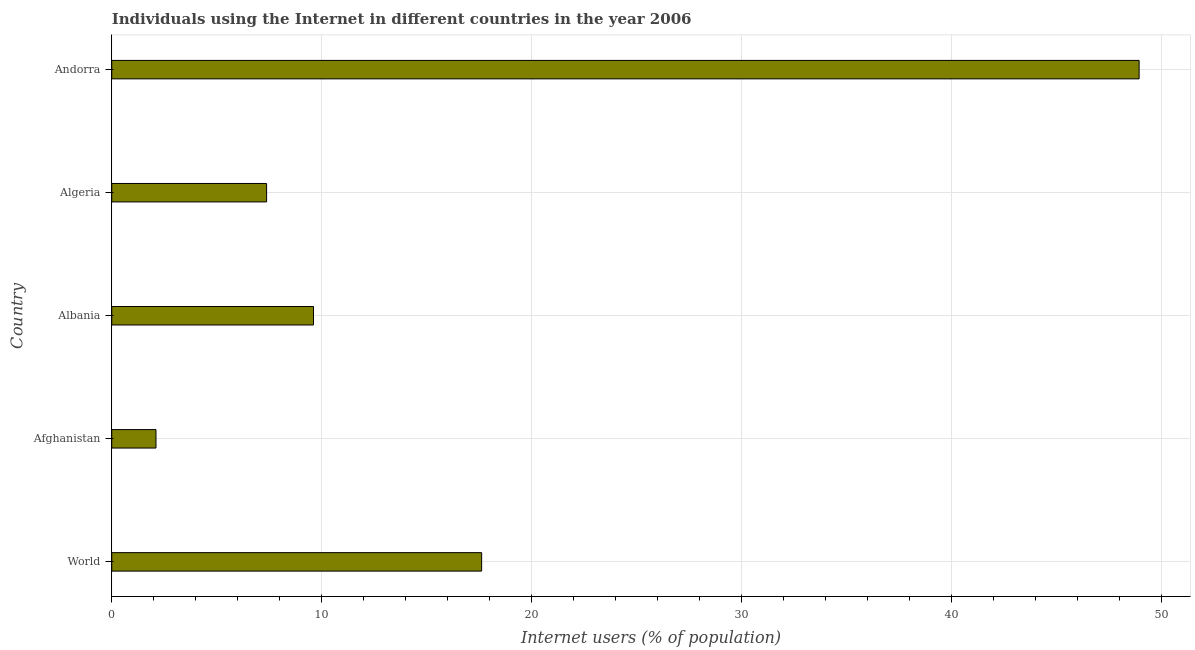Does the graph contain any zero values?
Keep it short and to the point. No. Does the graph contain grids?
Keep it short and to the point. Yes. What is the title of the graph?
Offer a terse response. Individuals using the Internet in different countries in the year 2006. What is the label or title of the X-axis?
Ensure brevity in your answer.  Internet users (% of population). What is the label or title of the Y-axis?
Offer a very short reply. Country. What is the number of internet users in World?
Offer a very short reply. 17.62. Across all countries, what is the maximum number of internet users?
Provide a short and direct response. 48.94. Across all countries, what is the minimum number of internet users?
Your answer should be very brief. 2.11. In which country was the number of internet users maximum?
Provide a succinct answer. Andorra. In which country was the number of internet users minimum?
Your response must be concise. Afghanistan. What is the sum of the number of internet users?
Offer a terse response. 85.65. What is the difference between the number of internet users in Afghanistan and Algeria?
Give a very brief answer. -5.27. What is the average number of internet users per country?
Offer a terse response. 17.13. What is the median number of internet users?
Keep it short and to the point. 9.61. In how many countries, is the number of internet users greater than 32 %?
Offer a very short reply. 1. What is the ratio of the number of internet users in Afghanistan to that in Albania?
Offer a terse response. 0.22. Is the number of internet users in Andorra less than that in World?
Keep it short and to the point. No. Is the difference between the number of internet users in Andorra and World greater than the difference between any two countries?
Keep it short and to the point. No. What is the difference between the highest and the second highest number of internet users?
Your answer should be compact. 31.32. What is the difference between the highest and the lowest number of internet users?
Give a very brief answer. 46.83. How many bars are there?
Your answer should be very brief. 5. Are all the bars in the graph horizontal?
Your answer should be compact. Yes. How many countries are there in the graph?
Your answer should be compact. 5. What is the difference between two consecutive major ticks on the X-axis?
Your answer should be compact. 10. Are the values on the major ticks of X-axis written in scientific E-notation?
Offer a very short reply. No. What is the Internet users (% of population) of World?
Ensure brevity in your answer.  17.62. What is the Internet users (% of population) in Afghanistan?
Ensure brevity in your answer.  2.11. What is the Internet users (% of population) of Albania?
Offer a terse response. 9.61. What is the Internet users (% of population) of Algeria?
Ensure brevity in your answer.  7.38. What is the Internet users (% of population) of Andorra?
Offer a very short reply. 48.94. What is the difference between the Internet users (% of population) in World and Afghanistan?
Give a very brief answer. 15.51. What is the difference between the Internet users (% of population) in World and Albania?
Your answer should be compact. 8.01. What is the difference between the Internet users (% of population) in World and Algeria?
Your answer should be compact. 10.24. What is the difference between the Internet users (% of population) in World and Andorra?
Ensure brevity in your answer.  -31.32. What is the difference between the Internet users (% of population) in Afghanistan and Albania?
Give a very brief answer. -7.5. What is the difference between the Internet users (% of population) in Afghanistan and Algeria?
Your answer should be very brief. -5.27. What is the difference between the Internet users (% of population) in Afghanistan and Andorra?
Keep it short and to the point. -46.83. What is the difference between the Internet users (% of population) in Albania and Algeria?
Your answer should be compact. 2.23. What is the difference between the Internet users (% of population) in Albania and Andorra?
Your answer should be very brief. -39.33. What is the difference between the Internet users (% of population) in Algeria and Andorra?
Offer a very short reply. -41.56. What is the ratio of the Internet users (% of population) in World to that in Afghanistan?
Your response must be concise. 8.36. What is the ratio of the Internet users (% of population) in World to that in Albania?
Give a very brief answer. 1.83. What is the ratio of the Internet users (% of population) in World to that in Algeria?
Your response must be concise. 2.39. What is the ratio of the Internet users (% of population) in World to that in Andorra?
Give a very brief answer. 0.36. What is the ratio of the Internet users (% of population) in Afghanistan to that in Albania?
Make the answer very short. 0.22. What is the ratio of the Internet users (% of population) in Afghanistan to that in Algeria?
Provide a succinct answer. 0.29. What is the ratio of the Internet users (% of population) in Afghanistan to that in Andorra?
Give a very brief answer. 0.04. What is the ratio of the Internet users (% of population) in Albania to that in Algeria?
Offer a very short reply. 1.3. What is the ratio of the Internet users (% of population) in Albania to that in Andorra?
Provide a short and direct response. 0.2. What is the ratio of the Internet users (% of population) in Algeria to that in Andorra?
Your answer should be very brief. 0.15. 